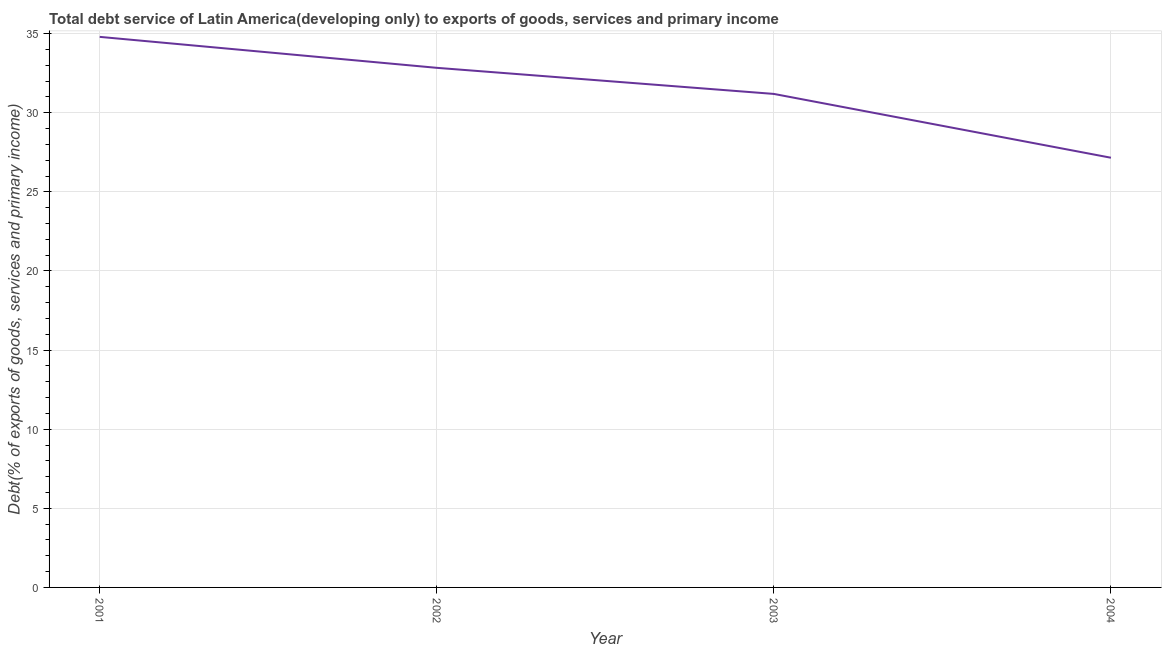What is the total debt service in 2002?
Your response must be concise. 32.84. Across all years, what is the maximum total debt service?
Ensure brevity in your answer.  34.8. Across all years, what is the minimum total debt service?
Your response must be concise. 27.16. In which year was the total debt service maximum?
Offer a terse response. 2001. What is the sum of the total debt service?
Ensure brevity in your answer.  125.98. What is the difference between the total debt service in 2002 and 2003?
Ensure brevity in your answer.  1.65. What is the average total debt service per year?
Keep it short and to the point. 31.5. What is the median total debt service?
Ensure brevity in your answer.  32.01. In how many years, is the total debt service greater than 31 %?
Make the answer very short. 3. What is the ratio of the total debt service in 2001 to that in 2002?
Your response must be concise. 1.06. What is the difference between the highest and the second highest total debt service?
Your answer should be very brief. 1.96. Is the sum of the total debt service in 2002 and 2003 greater than the maximum total debt service across all years?
Ensure brevity in your answer.  Yes. What is the difference between the highest and the lowest total debt service?
Offer a terse response. 7.64. In how many years, is the total debt service greater than the average total debt service taken over all years?
Offer a very short reply. 2. Does the total debt service monotonically increase over the years?
Keep it short and to the point. No. How many lines are there?
Provide a short and direct response. 1. How many years are there in the graph?
Your answer should be very brief. 4. Does the graph contain grids?
Provide a short and direct response. Yes. What is the title of the graph?
Ensure brevity in your answer.  Total debt service of Latin America(developing only) to exports of goods, services and primary income. What is the label or title of the X-axis?
Ensure brevity in your answer.  Year. What is the label or title of the Y-axis?
Give a very brief answer. Debt(% of exports of goods, services and primary income). What is the Debt(% of exports of goods, services and primary income) in 2001?
Ensure brevity in your answer.  34.8. What is the Debt(% of exports of goods, services and primary income) in 2002?
Offer a terse response. 32.84. What is the Debt(% of exports of goods, services and primary income) in 2003?
Your response must be concise. 31.19. What is the Debt(% of exports of goods, services and primary income) of 2004?
Keep it short and to the point. 27.16. What is the difference between the Debt(% of exports of goods, services and primary income) in 2001 and 2002?
Your response must be concise. 1.96. What is the difference between the Debt(% of exports of goods, services and primary income) in 2001 and 2003?
Provide a short and direct response. 3.61. What is the difference between the Debt(% of exports of goods, services and primary income) in 2001 and 2004?
Your answer should be very brief. 7.64. What is the difference between the Debt(% of exports of goods, services and primary income) in 2002 and 2003?
Make the answer very short. 1.65. What is the difference between the Debt(% of exports of goods, services and primary income) in 2002 and 2004?
Ensure brevity in your answer.  5.68. What is the difference between the Debt(% of exports of goods, services and primary income) in 2003 and 2004?
Your response must be concise. 4.03. What is the ratio of the Debt(% of exports of goods, services and primary income) in 2001 to that in 2002?
Give a very brief answer. 1.06. What is the ratio of the Debt(% of exports of goods, services and primary income) in 2001 to that in 2003?
Your answer should be very brief. 1.12. What is the ratio of the Debt(% of exports of goods, services and primary income) in 2001 to that in 2004?
Keep it short and to the point. 1.28. What is the ratio of the Debt(% of exports of goods, services and primary income) in 2002 to that in 2003?
Give a very brief answer. 1.05. What is the ratio of the Debt(% of exports of goods, services and primary income) in 2002 to that in 2004?
Your response must be concise. 1.21. What is the ratio of the Debt(% of exports of goods, services and primary income) in 2003 to that in 2004?
Ensure brevity in your answer.  1.15. 